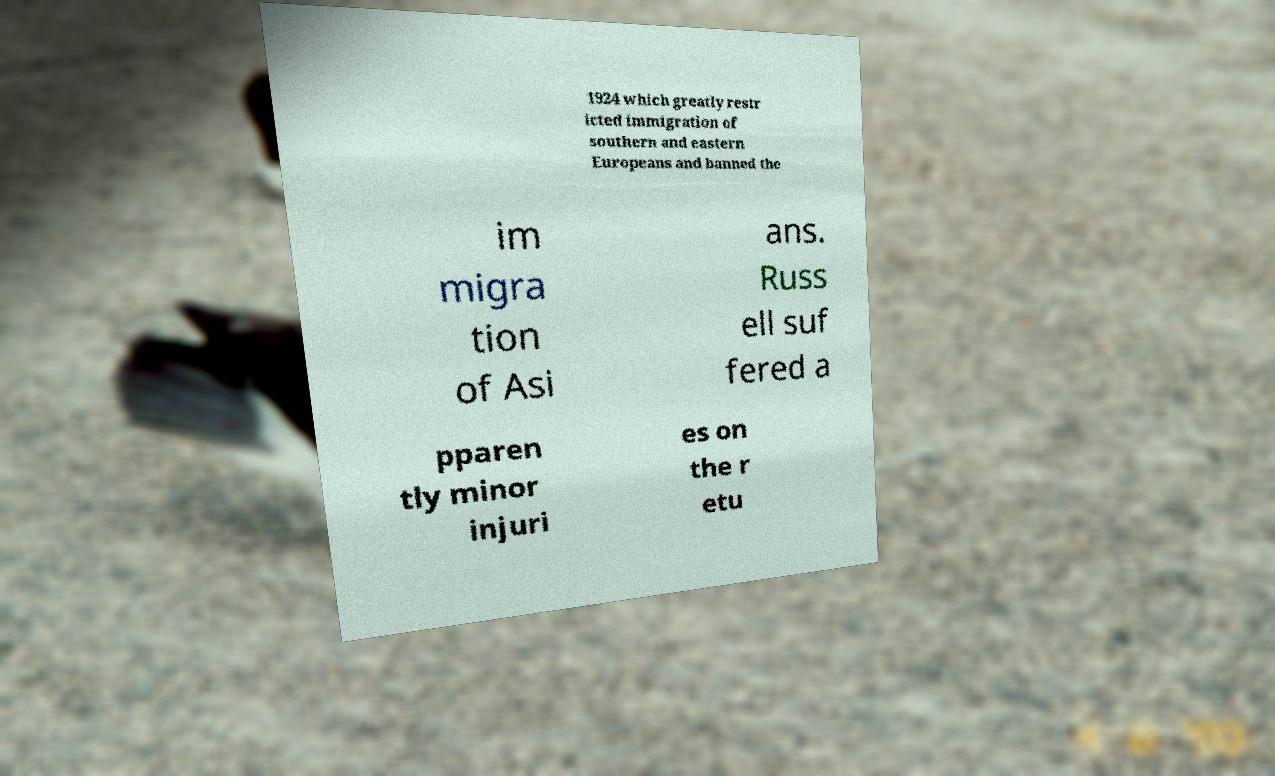For documentation purposes, I need the text within this image transcribed. Could you provide that? 1924 which greatly restr icted immigration of southern and eastern Europeans and banned the im migra tion of Asi ans. Russ ell suf fered a pparen tly minor injuri es on the r etu 